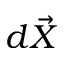Convert formula to latex. <formula><loc_0><loc_0><loc_500><loc_500>d \vec { X }</formula> 